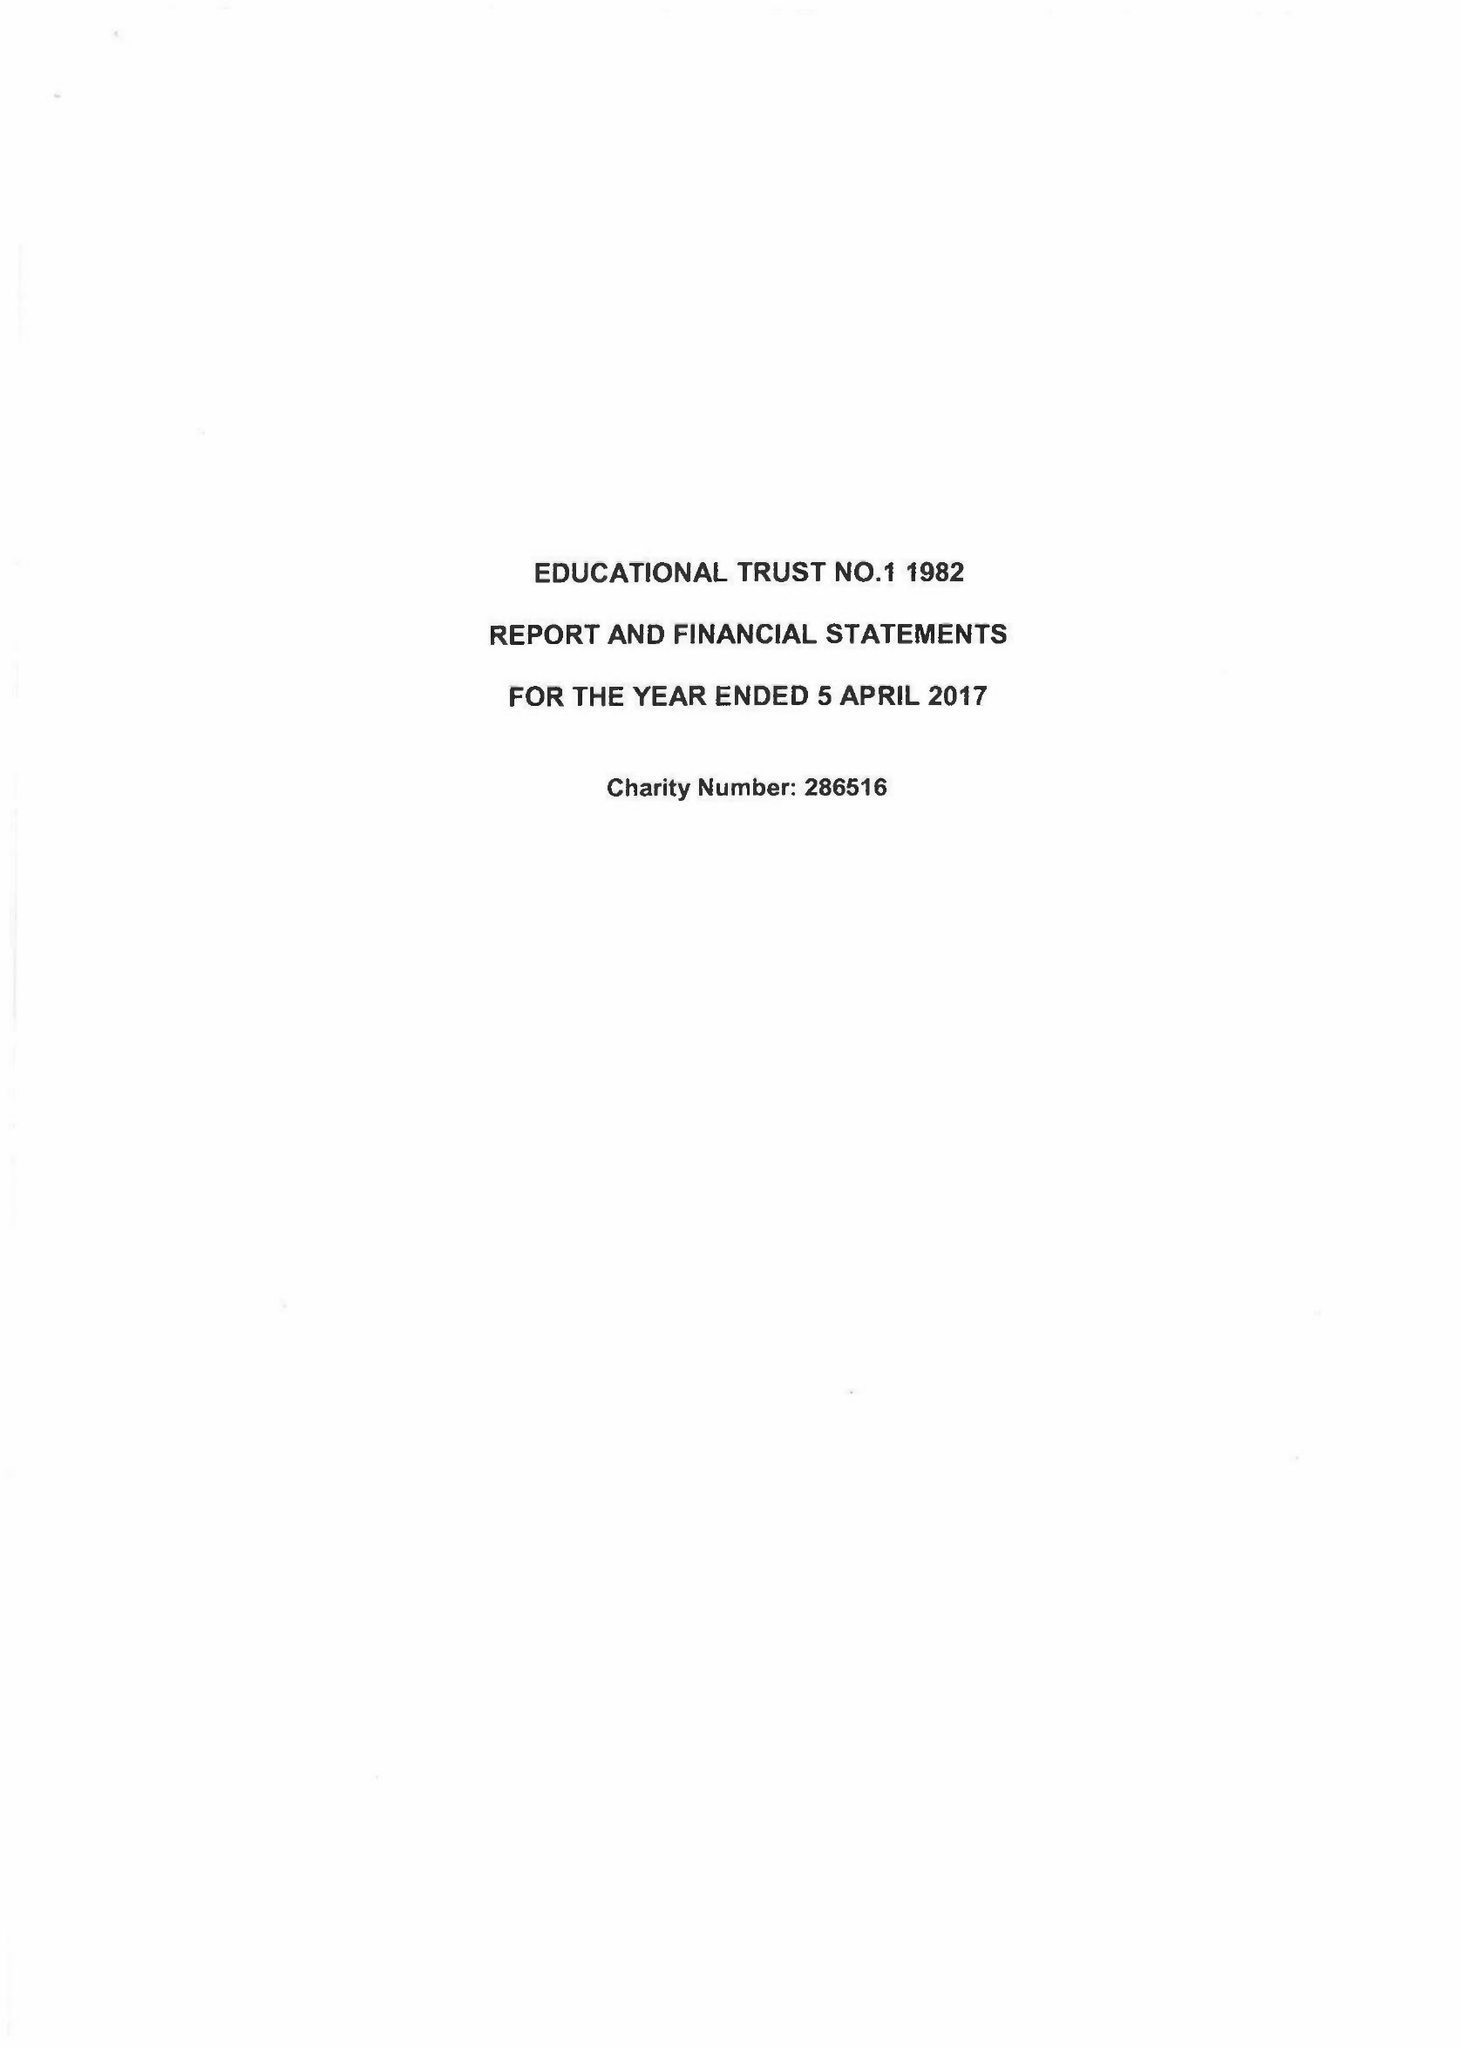What is the value for the charity_number?
Answer the question using a single word or phrase. 286516 